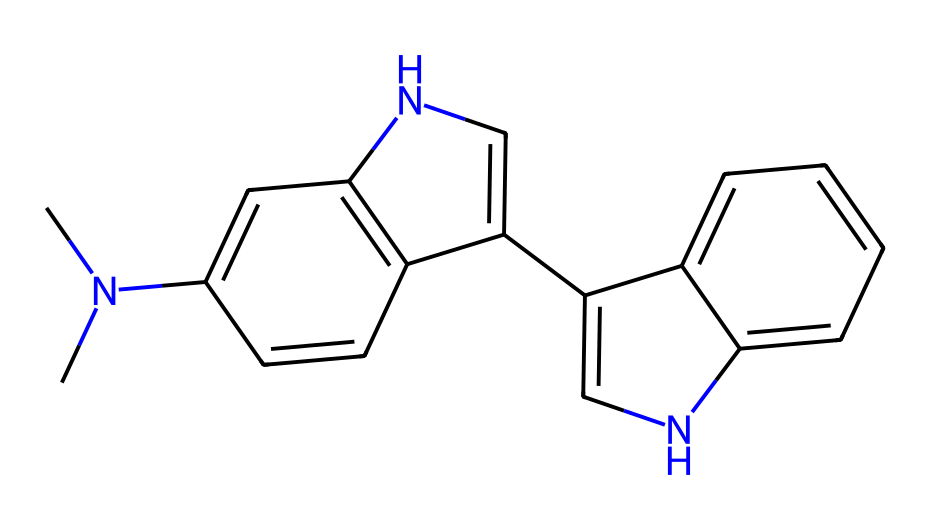What is the molecular formula of this compound? By analyzing the SMILES representation, we can count the number of each type of atom present. Each letter corresponds to a different element, and by identifying them in the given structure, we find 14 carbons, 18 hydrogens, 4 nitrogens, and no oxygens. Therefore, the molecular formula is derived from these counts.
Answer: C14H18N4 How many rings are present in this chemical structure? In the visual representation of the SMILES structure, we observe several cycles created by the connection points between carbon atoms. Specifically, there are three ring systems identified, showcasing the complexity often found in alkaloids.
Answer: 3 What type of chemical is this compound categorized as? The presence of nitrogen atoms and the structural features typical of these compounds, combined with its origin in plants, classifies this compound as an alkaloid. Alkaloids are often known for their psychoactive properties and therapeutic potential.
Answer: alkaloid What is the significance of the nitrogen atoms in this molecule? Nitrogen atoms in alkaloids typically contribute to biological activity, affecting receptors in the nervous system and lending to psychoactive properties. In this compound, their presence indicates potential interactions in spiritual and therapeutic contexts.
Answer: psychoactive activity How many double bonds are detected in this compound? By examining the structure in the SMILES notation, we see there are 5 double bonds noted by the "=" sign. These double bonds are critical as they affect the reactivity and stability of the molecule.
Answer: 5 